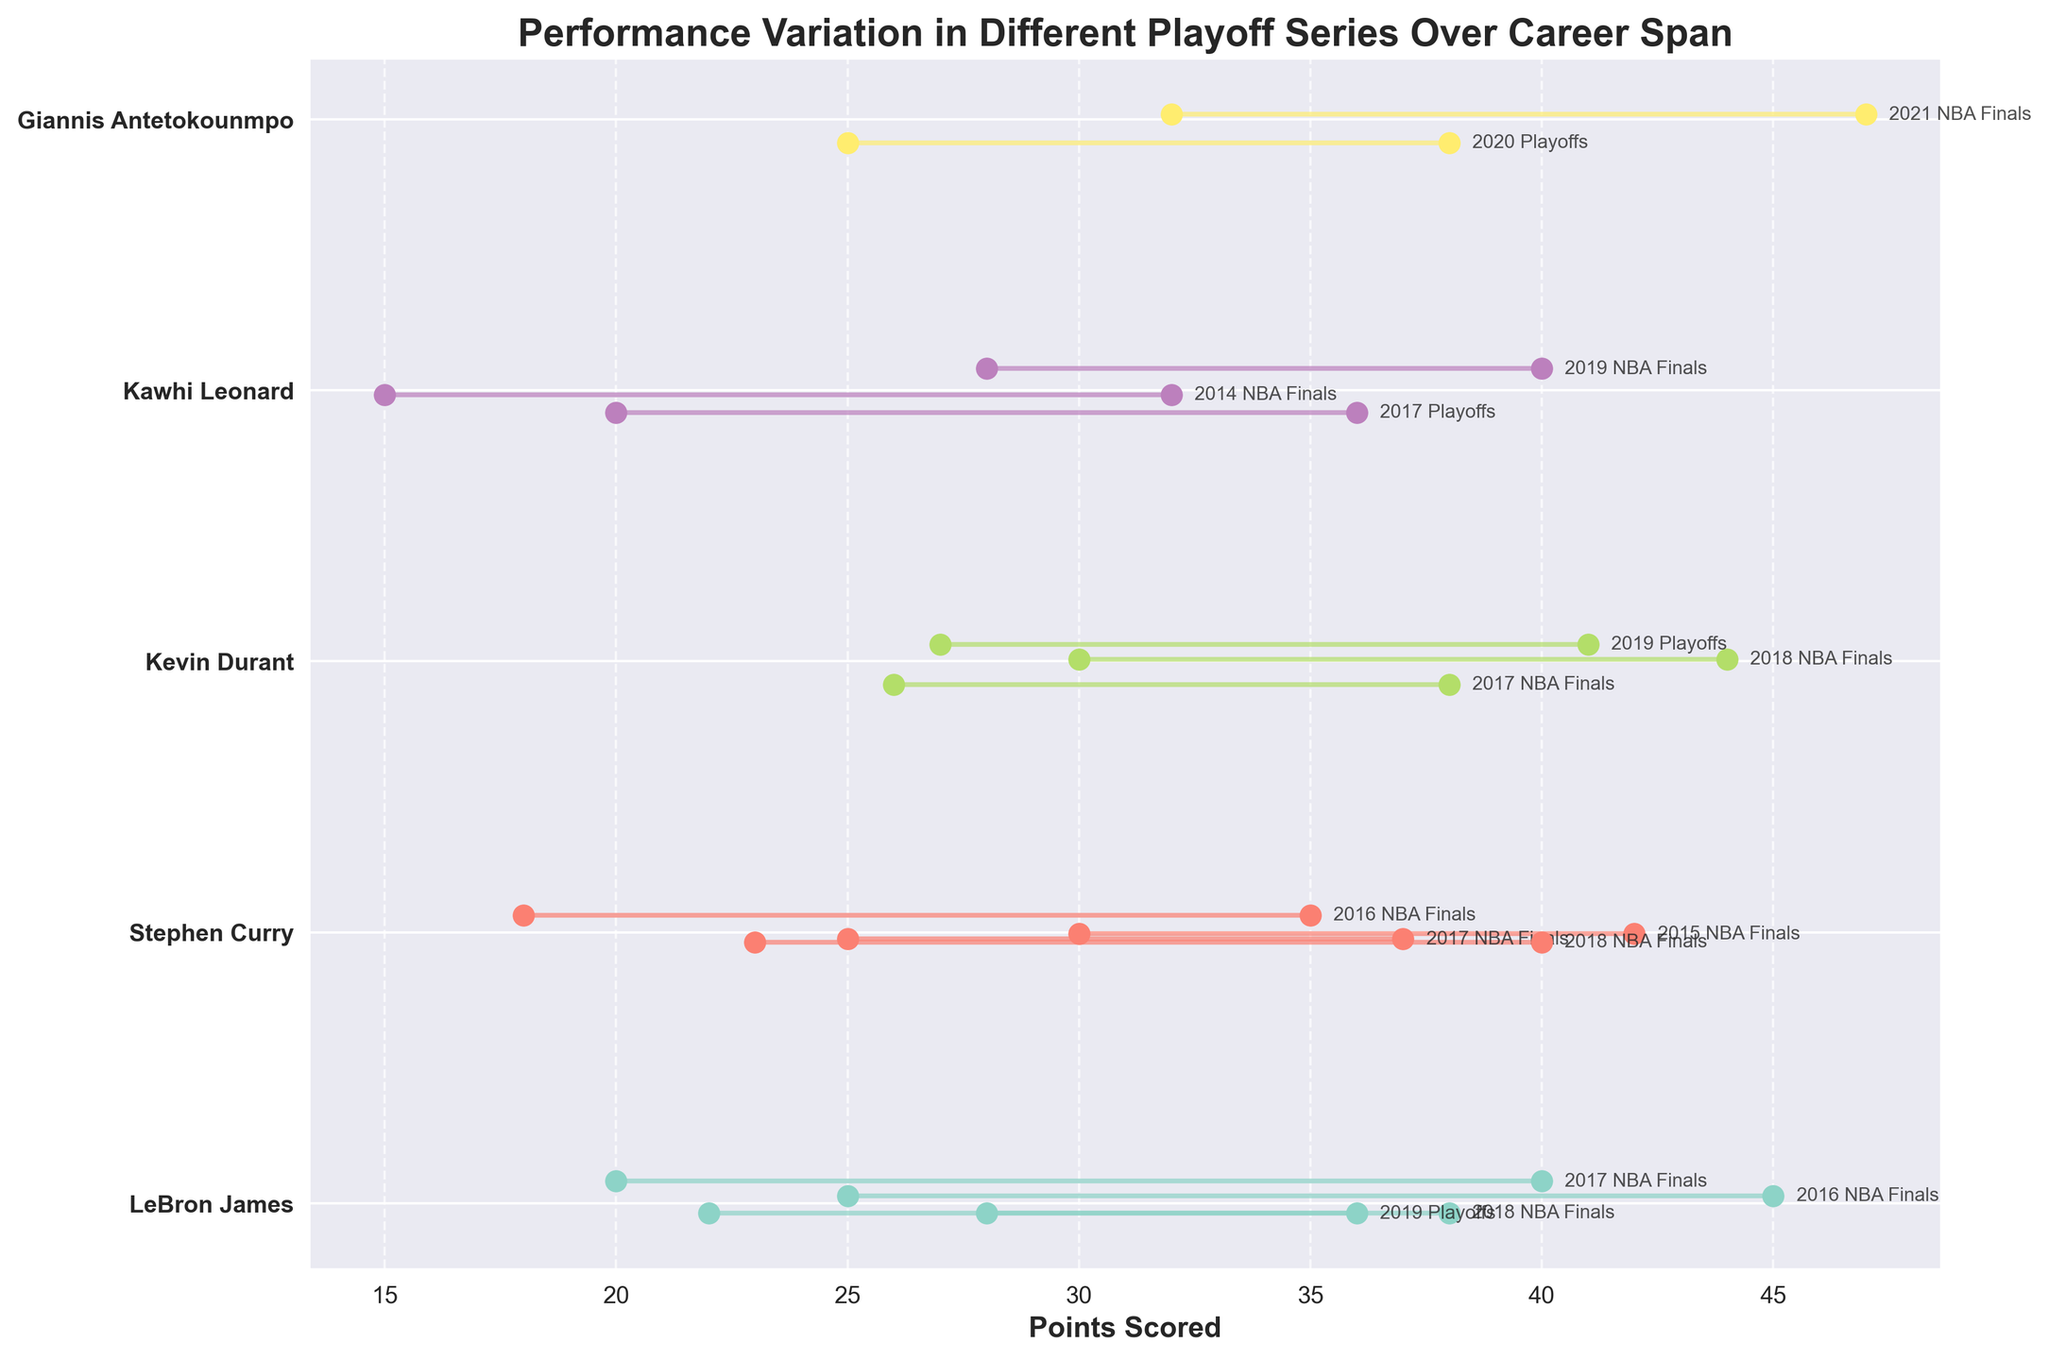What is the title of the figure? The title is located at the top of the figure, and it summarizes the overall content of the plot.
Answer: Performance Variation in Different Playoff Series Over Career Span Which player has the highest recorded range in points scored, and in which series? The highest recorded range is found by looking at the length of the lines, comparing the difference between Min and Max points. Giannis Antetokounmpo in the 2021 NBA Finals has the highest range from 32 to 47.
Answer: Giannis Antetokounmpo, 2021 NBA Finals What is the color scheme used for a specific player in the figure? Each player has a unique color assigned to their data points and lines; use the legend or visually compare the colors.
Answer: Set3 colormap with unique colors for each player How many series are represented for Stephen Curry? Count the number of lines or data points associated with Stephen Curry on the plot. There are four lines for Stephen Curry.
Answer: 4 Which player shows the least variation in a single series, and what are the points? Identify the shortest line, indicating the smallest difference between Min and Max points. Stephen Curry in the 2016 NBA Finals has the least variation with a range from 18 to 35.
Answer: Stephen Curry, 2016 NBA Finals Compare LeBron James' performance variation in the 2016 NBA Finals and the 2017 NBA Finals. Look at the lines corresponding to LeBron James for these two series and compare the differences between Min and Max points. For 2016 NBA Finals, the range is 25 to 45; for 2017 NBA Finals, it is 20 to 40. The ranges are 20 and 20, respectively, so the variations are the same.
Answer: Equal Which player had the maximum number of playoff series represented and how many were there? Count the unique series entries for each player. LeBron James has the maximum number with four series.
Answer: LeBron James, 4 How does Giannis Antetokounmpo's performance in the 2020 Playoffs compare to the 2021 NBA Finals in terms of range? Compare the length of the lines for these two series. For 2020 Playoffs, the range is 25 to 38 (13 points), and for 2021 NBA Finals, it is 32 to 47 (15 points). The 2021 NBA Finals has a wider range.
Answer: 2021 NBA Finals has a wider range For the player with the lowest recorded Min points, what is the corresponding series? Find the lowest Min value and check the corresponding player and series. Kawhi Leonard in the 2014 NBA Finals has the lowest Min points of 15.
Answer: Kawhi Leonard, 2014 NBA Finals What's the average of the maximum points scored for Kevin Durant across all represented series? Sum the Max points for Kevin Durant and divide by the number of represented series. The maximums are 38, 44, and 41, summing to 123. Divide by 3 for the average: 123 / 3 = 41.
Answer: 41 